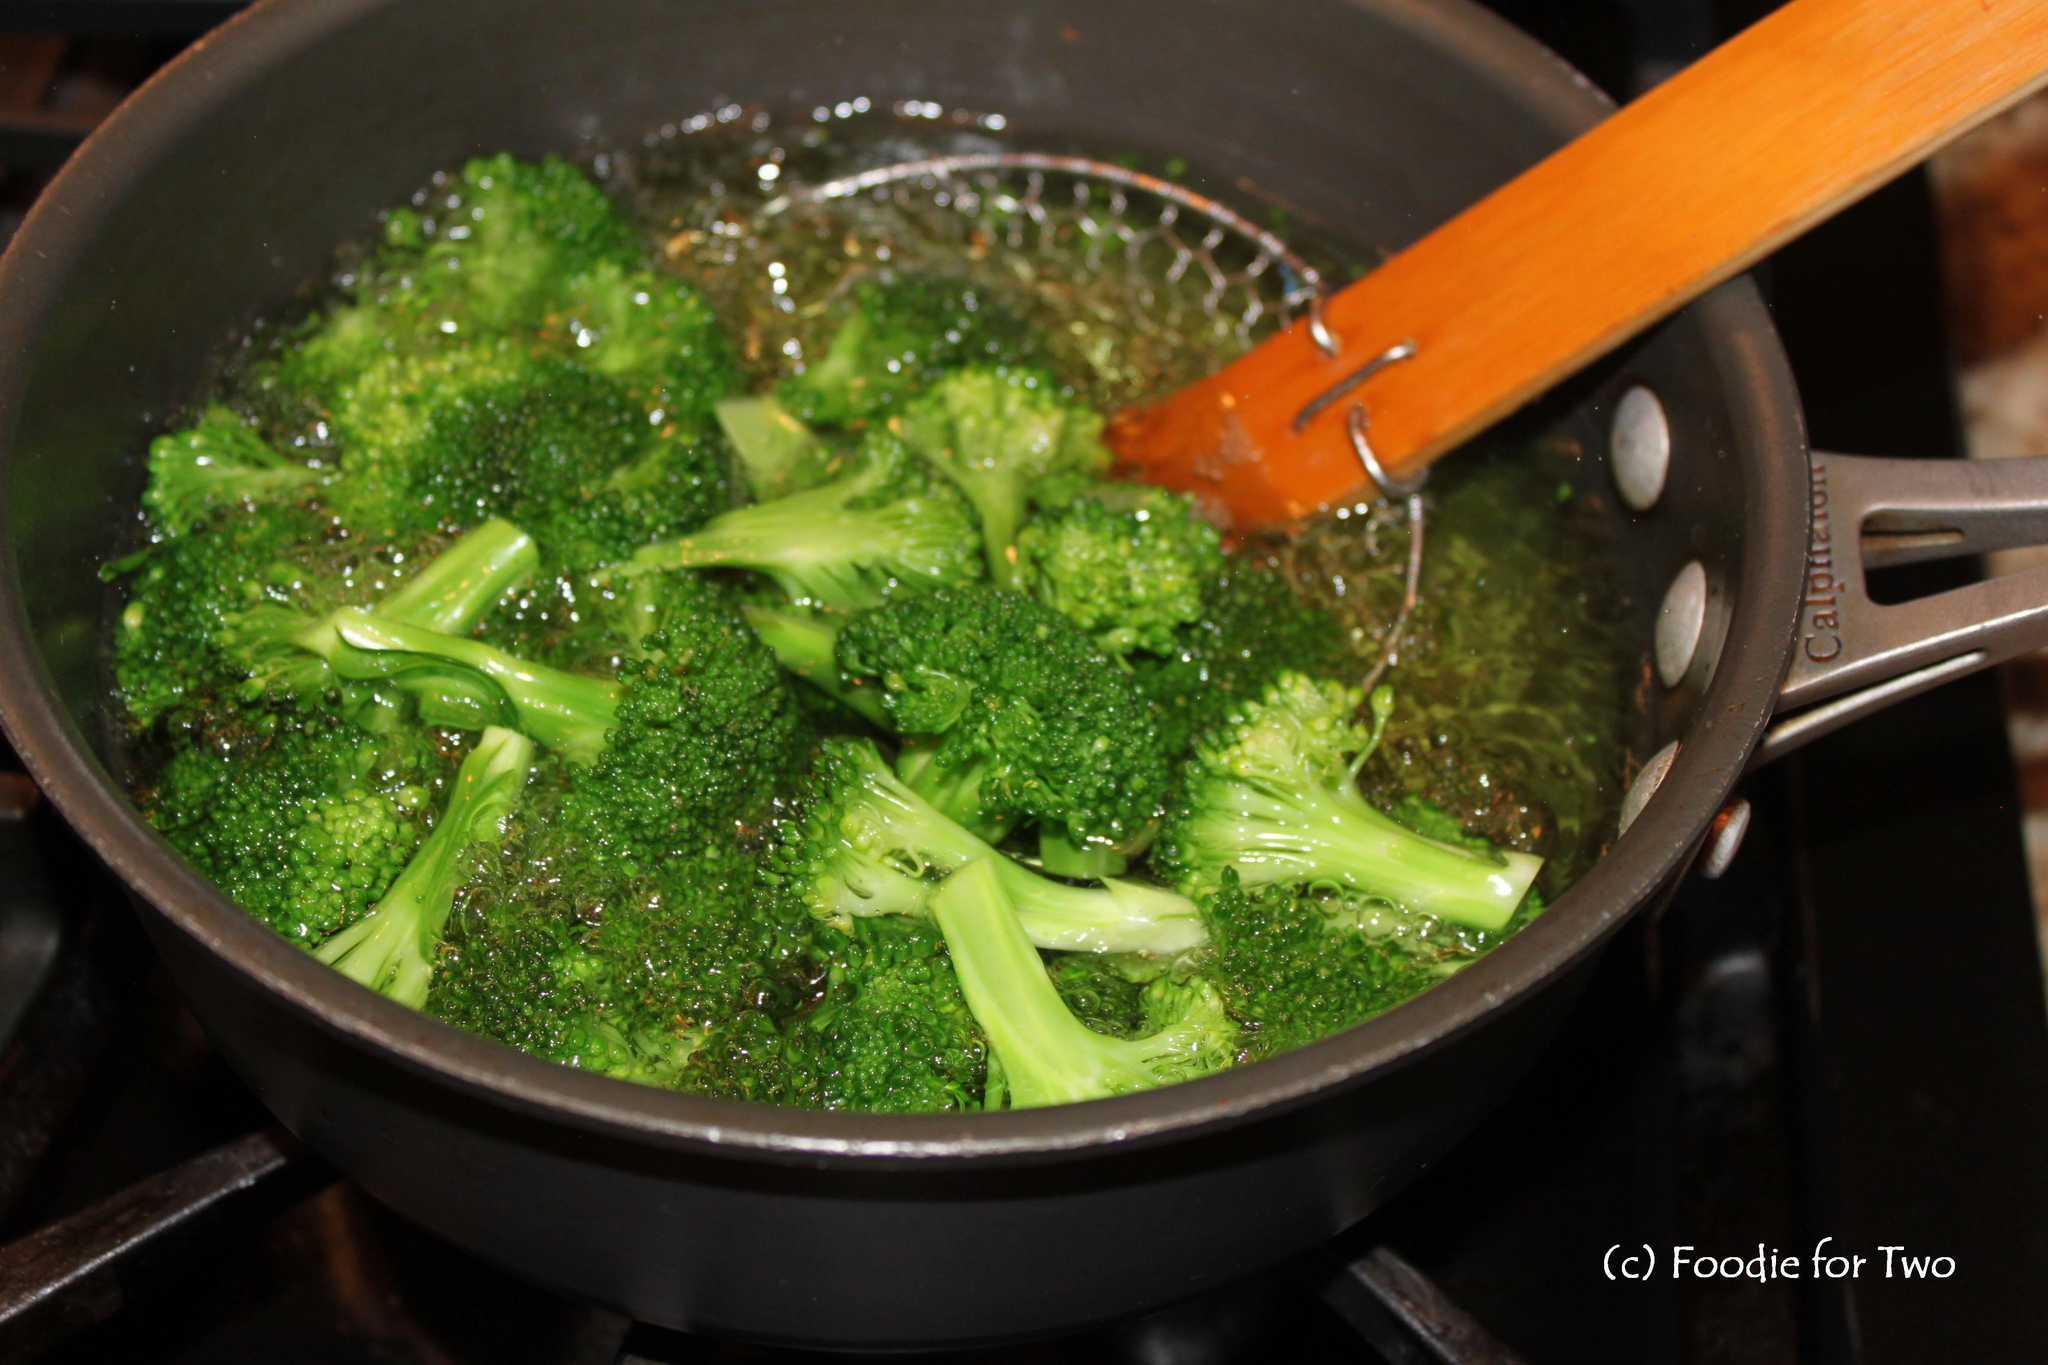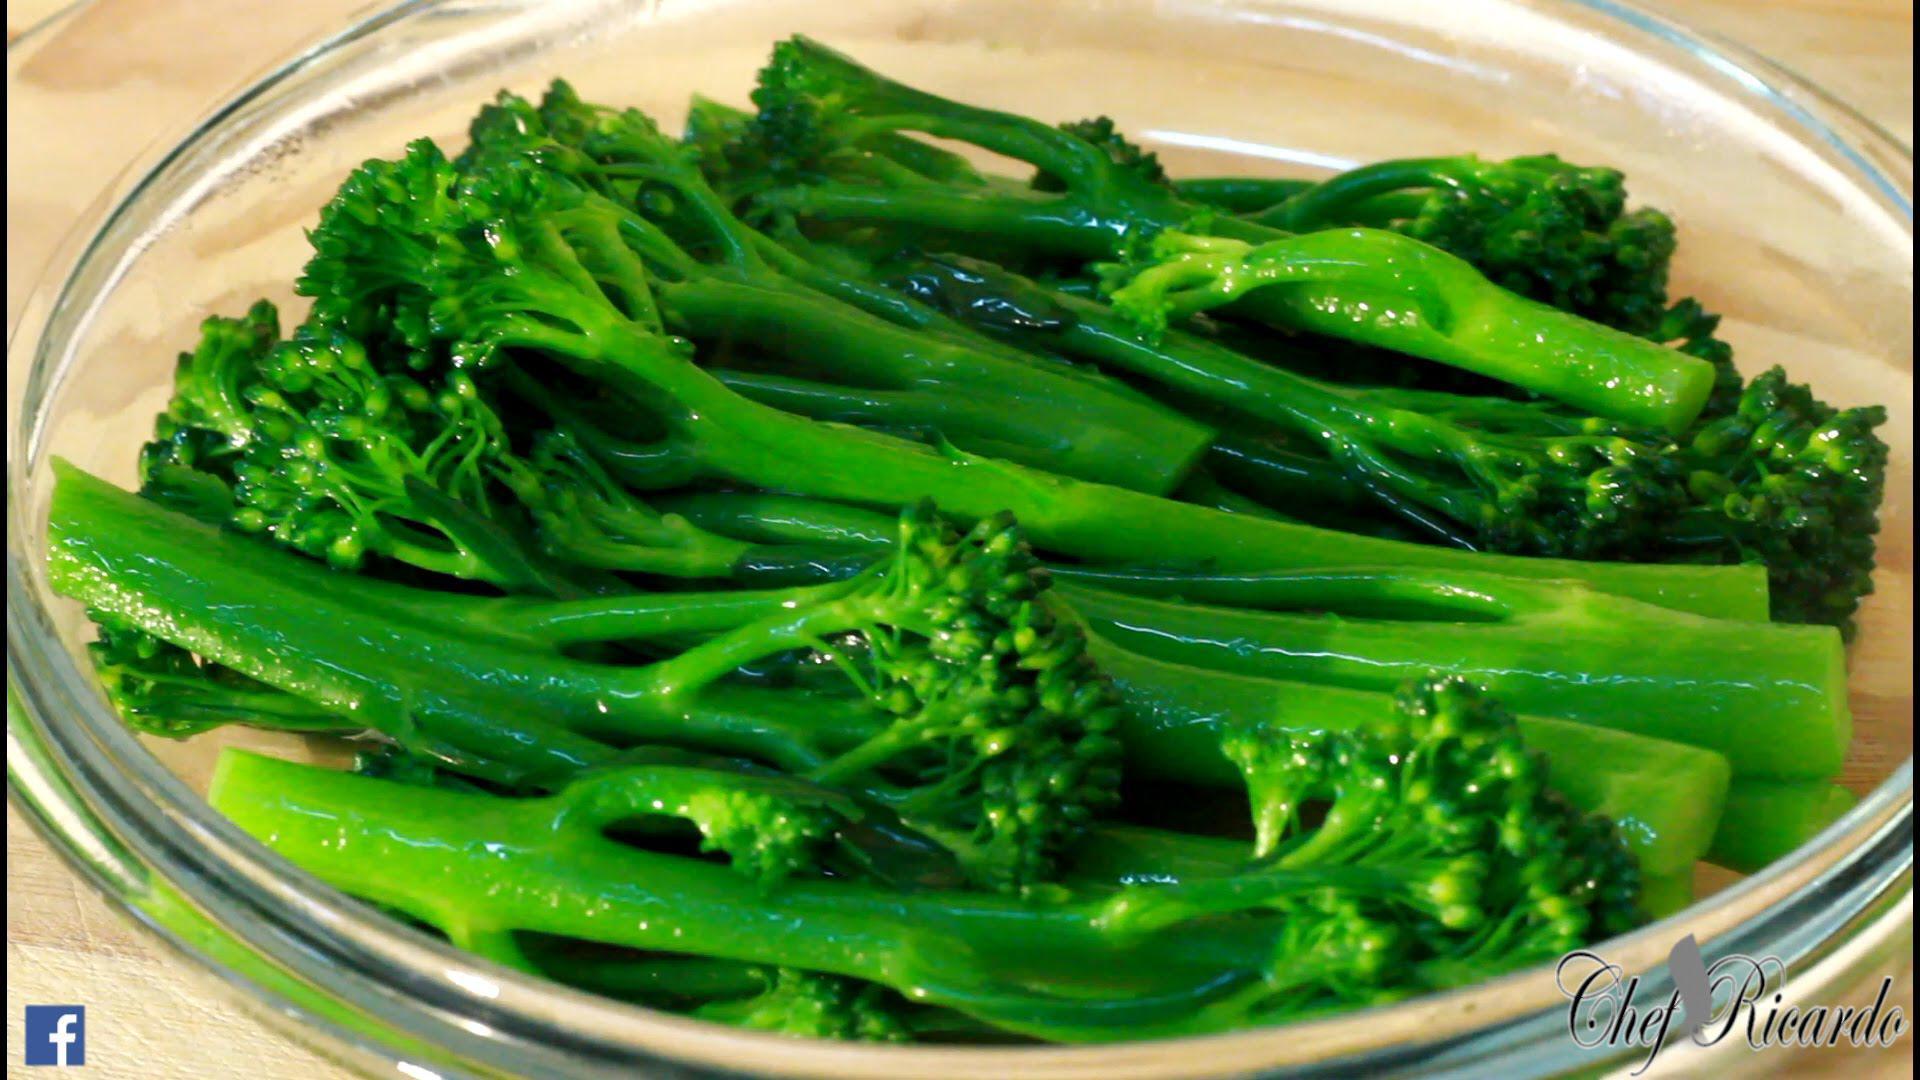The first image is the image on the left, the second image is the image on the right. Analyze the images presented: Is the assertion "An image shows a round dish that contains only broccoli." valid? Answer yes or no. Yes. The first image is the image on the left, the second image is the image on the right. Evaluate the accuracy of this statement regarding the images: "There are two veggies shown in the image on the left.". Is it true? Answer yes or no. No. 